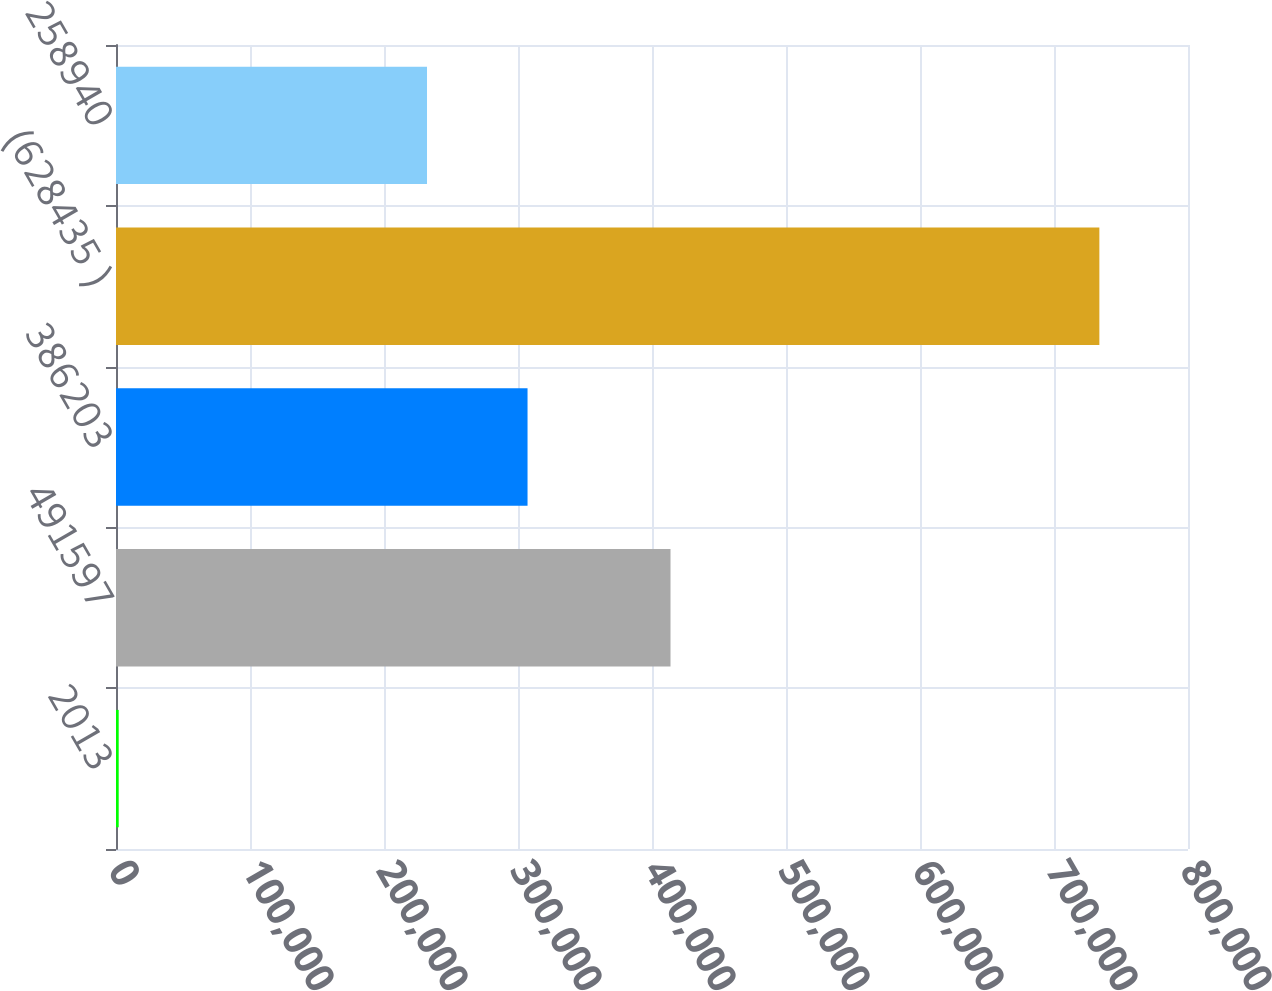Convert chart. <chart><loc_0><loc_0><loc_500><loc_500><bar_chart><fcel>2013<fcel>491597<fcel>386203<fcel>(628435 )<fcel>258940<nl><fcel>2011<fcel>413813<fcel>307118<fcel>733855<fcel>232099<nl></chart> 